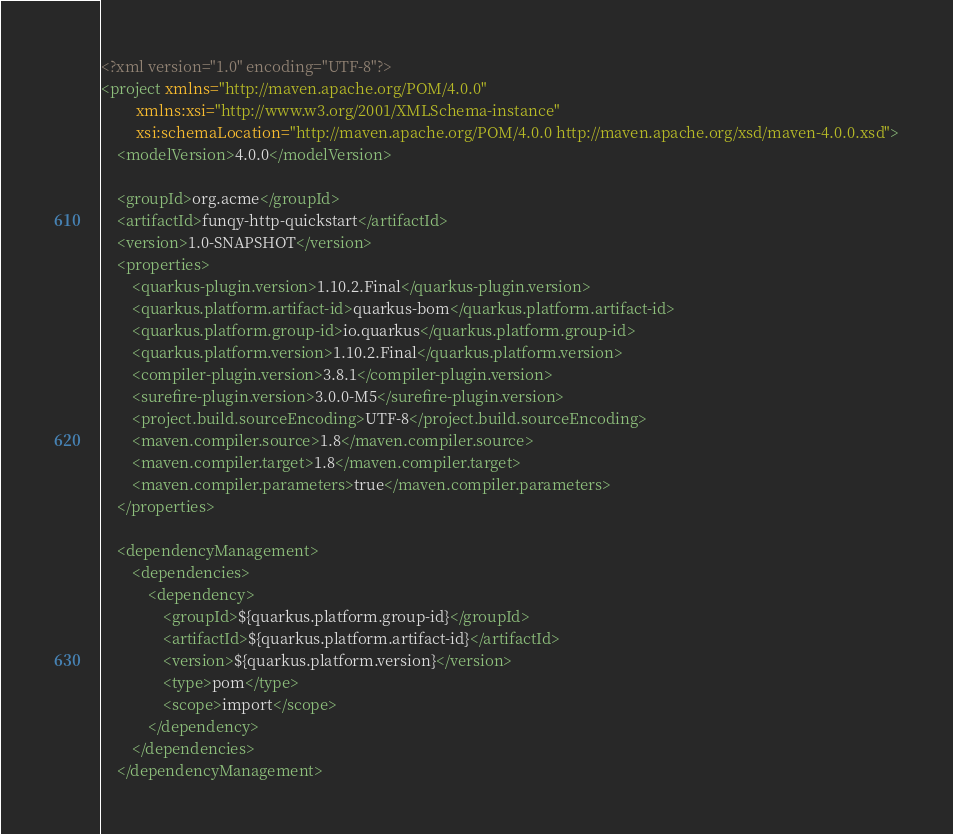Convert code to text. <code><loc_0><loc_0><loc_500><loc_500><_XML_><?xml version="1.0" encoding="UTF-8"?>
<project xmlns="http://maven.apache.org/POM/4.0.0"
         xmlns:xsi="http://www.w3.org/2001/XMLSchema-instance"
         xsi:schemaLocation="http://maven.apache.org/POM/4.0.0 http://maven.apache.org/xsd/maven-4.0.0.xsd">
    <modelVersion>4.0.0</modelVersion>

    <groupId>org.acme</groupId>
    <artifactId>funqy-http-quickstart</artifactId>
    <version>1.0-SNAPSHOT</version>
    <properties>
        <quarkus-plugin.version>1.10.2.Final</quarkus-plugin.version>
        <quarkus.platform.artifact-id>quarkus-bom</quarkus.platform.artifact-id>
        <quarkus.platform.group-id>io.quarkus</quarkus.platform.group-id>
        <quarkus.platform.version>1.10.2.Final</quarkus.platform.version>
        <compiler-plugin.version>3.8.1</compiler-plugin.version>
        <surefire-plugin.version>3.0.0-M5</surefire-plugin.version>
        <project.build.sourceEncoding>UTF-8</project.build.sourceEncoding>
        <maven.compiler.source>1.8</maven.compiler.source>
        <maven.compiler.target>1.8</maven.compiler.target>
        <maven.compiler.parameters>true</maven.compiler.parameters>
    </properties>

    <dependencyManagement>
        <dependencies>
            <dependency>
                <groupId>${quarkus.platform.group-id}</groupId>
                <artifactId>${quarkus.platform.artifact-id}</artifactId>
                <version>${quarkus.platform.version}</version>
                <type>pom</type>
                <scope>import</scope>
            </dependency>
        </dependencies>
    </dependencyManagement>
</code> 